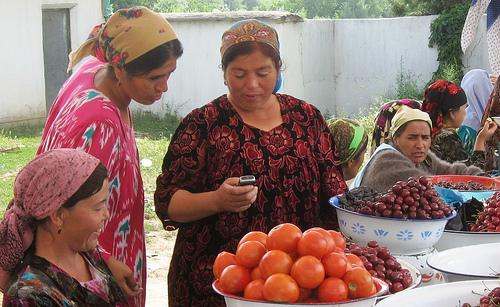The largest food item on any of these tables is found in what sauce?

Choices:
A) duck
B) ketchup
C) soy
D) mustard ketchup 